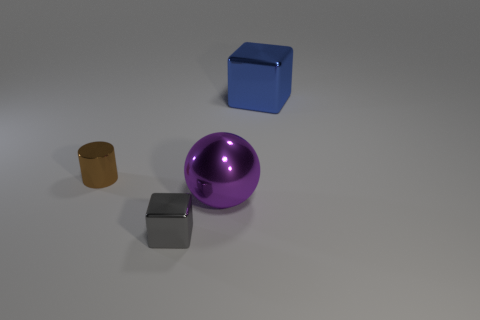Add 1 tiny green matte objects. How many objects exist? 5 Subtract all cylinders. How many objects are left? 3 Add 3 small green rubber objects. How many small green rubber objects exist? 3 Subtract 0 cyan cubes. How many objects are left? 4 Subtract all cylinders. Subtract all small brown shiny things. How many objects are left? 2 Add 2 big blue things. How many big blue things are left? 3 